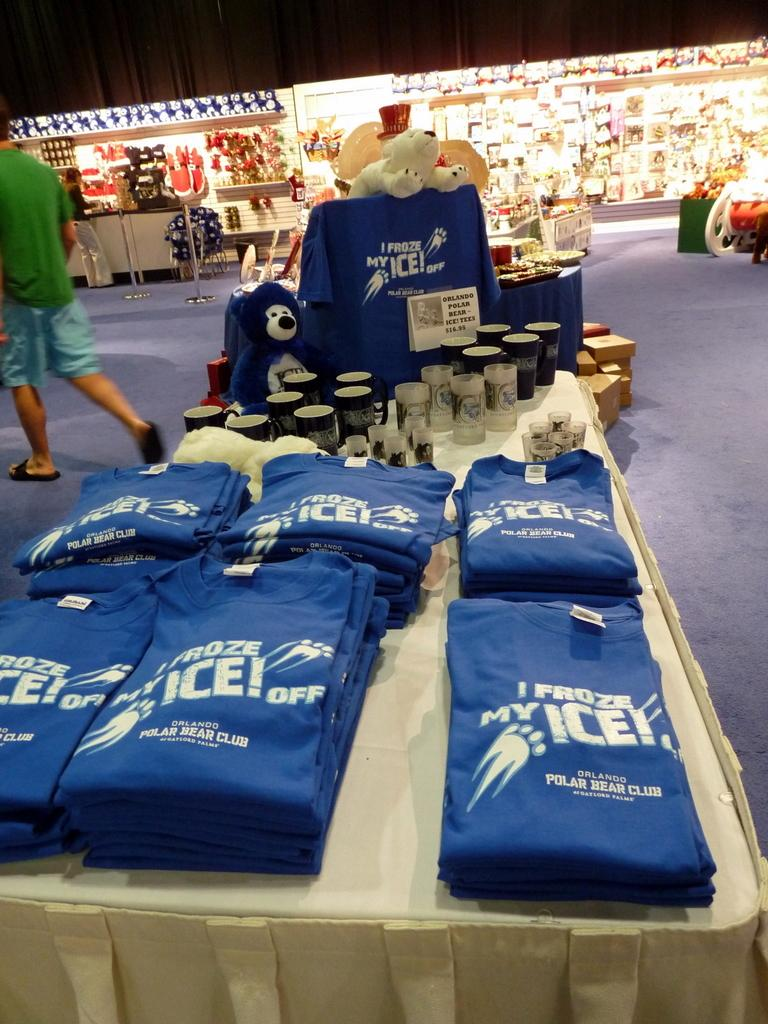<image>
Share a concise interpretation of the image provided. some shirts with the word ice on them 